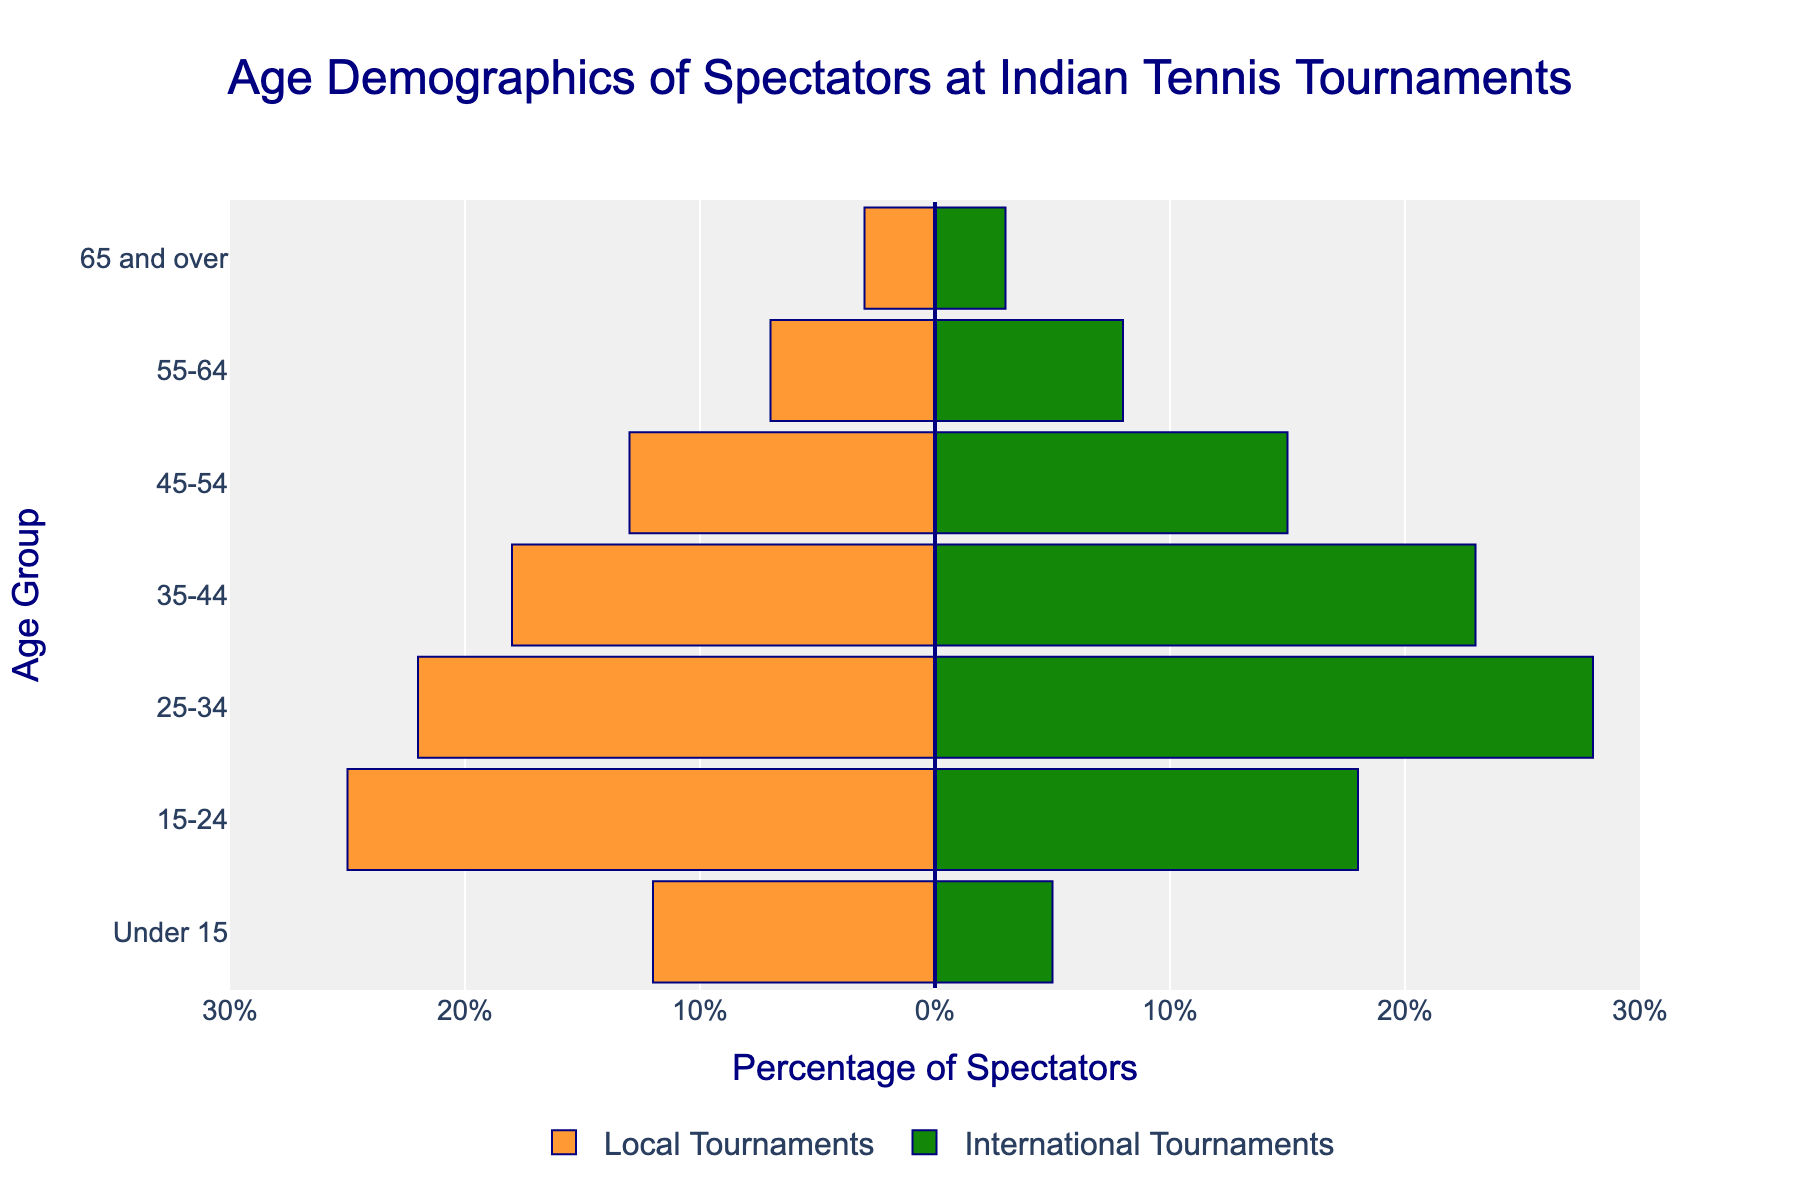What is the title of the plot? The title is located at the top center of the plot. By reading the text in this area, we can identify the title.
Answer: Age Demographics of Spectators at Indian Tennis Tournaments Which age group has the highest percentage of spectators in local tournaments? To find the age group with the highest percentage, look for the longest bar extending to the left from the center. This indicates the highest percentage value for local tournaments. The age group with the longest bar is 15-24.
Answer: 15-24 Which age group has the smallest difference in spectator percentages between local and international tournaments? To determine the smallest difference, we should subtract the percentage values of local and international tournaments for each age group and find the smallest result.
Answer: 65 and over What is the combined percentage of spectators aged 25-34 at both local and international tournaments? Add the percentage of spectators aged 25-34 at local tournaments and the percentage at international tournaments together (22% + 28%).
Answer: 50% In which age group are spectators more common in international tournaments than in local tournaments? Compare the lengths of the bars extending to the right (international tournaments) with those extending to the left (local tournaments) for each age group.
Answer: 25-34, 35-44, 45-54, 55-64 How does the percentage of spectators aged 35-44 in local tournaments compare to the percentage in international tournaments? After identifying the age group 35-44, compare the lengths of the bars: the left bar represents local tournaments, and the right bar represents international tournaments. The comparison shows the lengths of 18% (local) and 23% (international).
Answer: Lower in local What is the percentage of spectators aged 45-54 at international tournaments? Locate the age group of 45-54 and examine the length of the bar extending to the right which represents the international tournaments.
Answer: 15% Between spectators aged under 15 and those aged 55-64, which group has a greater representation at local tournaments? Compare the bars extending left for both age groups. The bar for under 15 (12%) is longer than the bar for 55-64 (7%).
Answer: Under 15 Do any age groups have an equal percentage of spectators at both local and international tournaments? Compare the lengths of bars on both sides for each age group. The bars with equal lengths represent equal percentages in both types of tournaments. For the age group 65 and over, both sides have the same length of bar.
Answer: 65 and over 